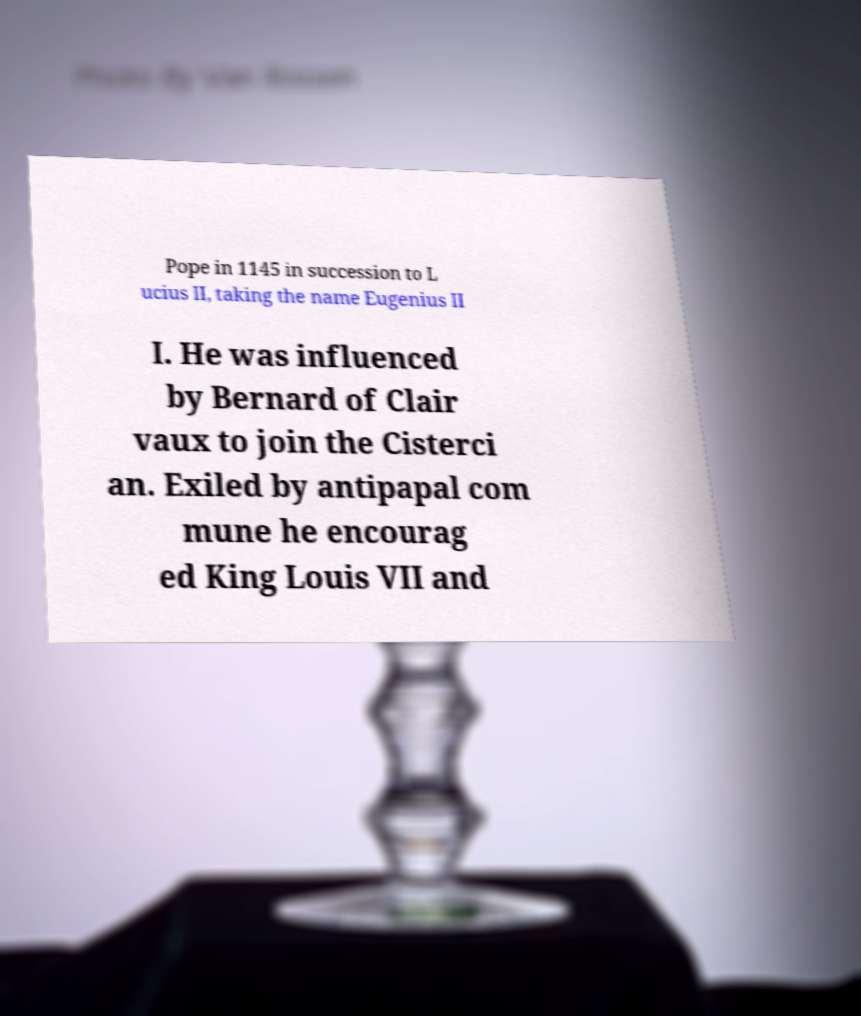Can you read and provide the text displayed in the image?This photo seems to have some interesting text. Can you extract and type it out for me? Pope in 1145 in succession to L ucius II, taking the name Eugenius II I. He was influenced by Bernard of Clair vaux to join the Cisterci an. Exiled by antipapal com mune he encourag ed King Louis VII and 